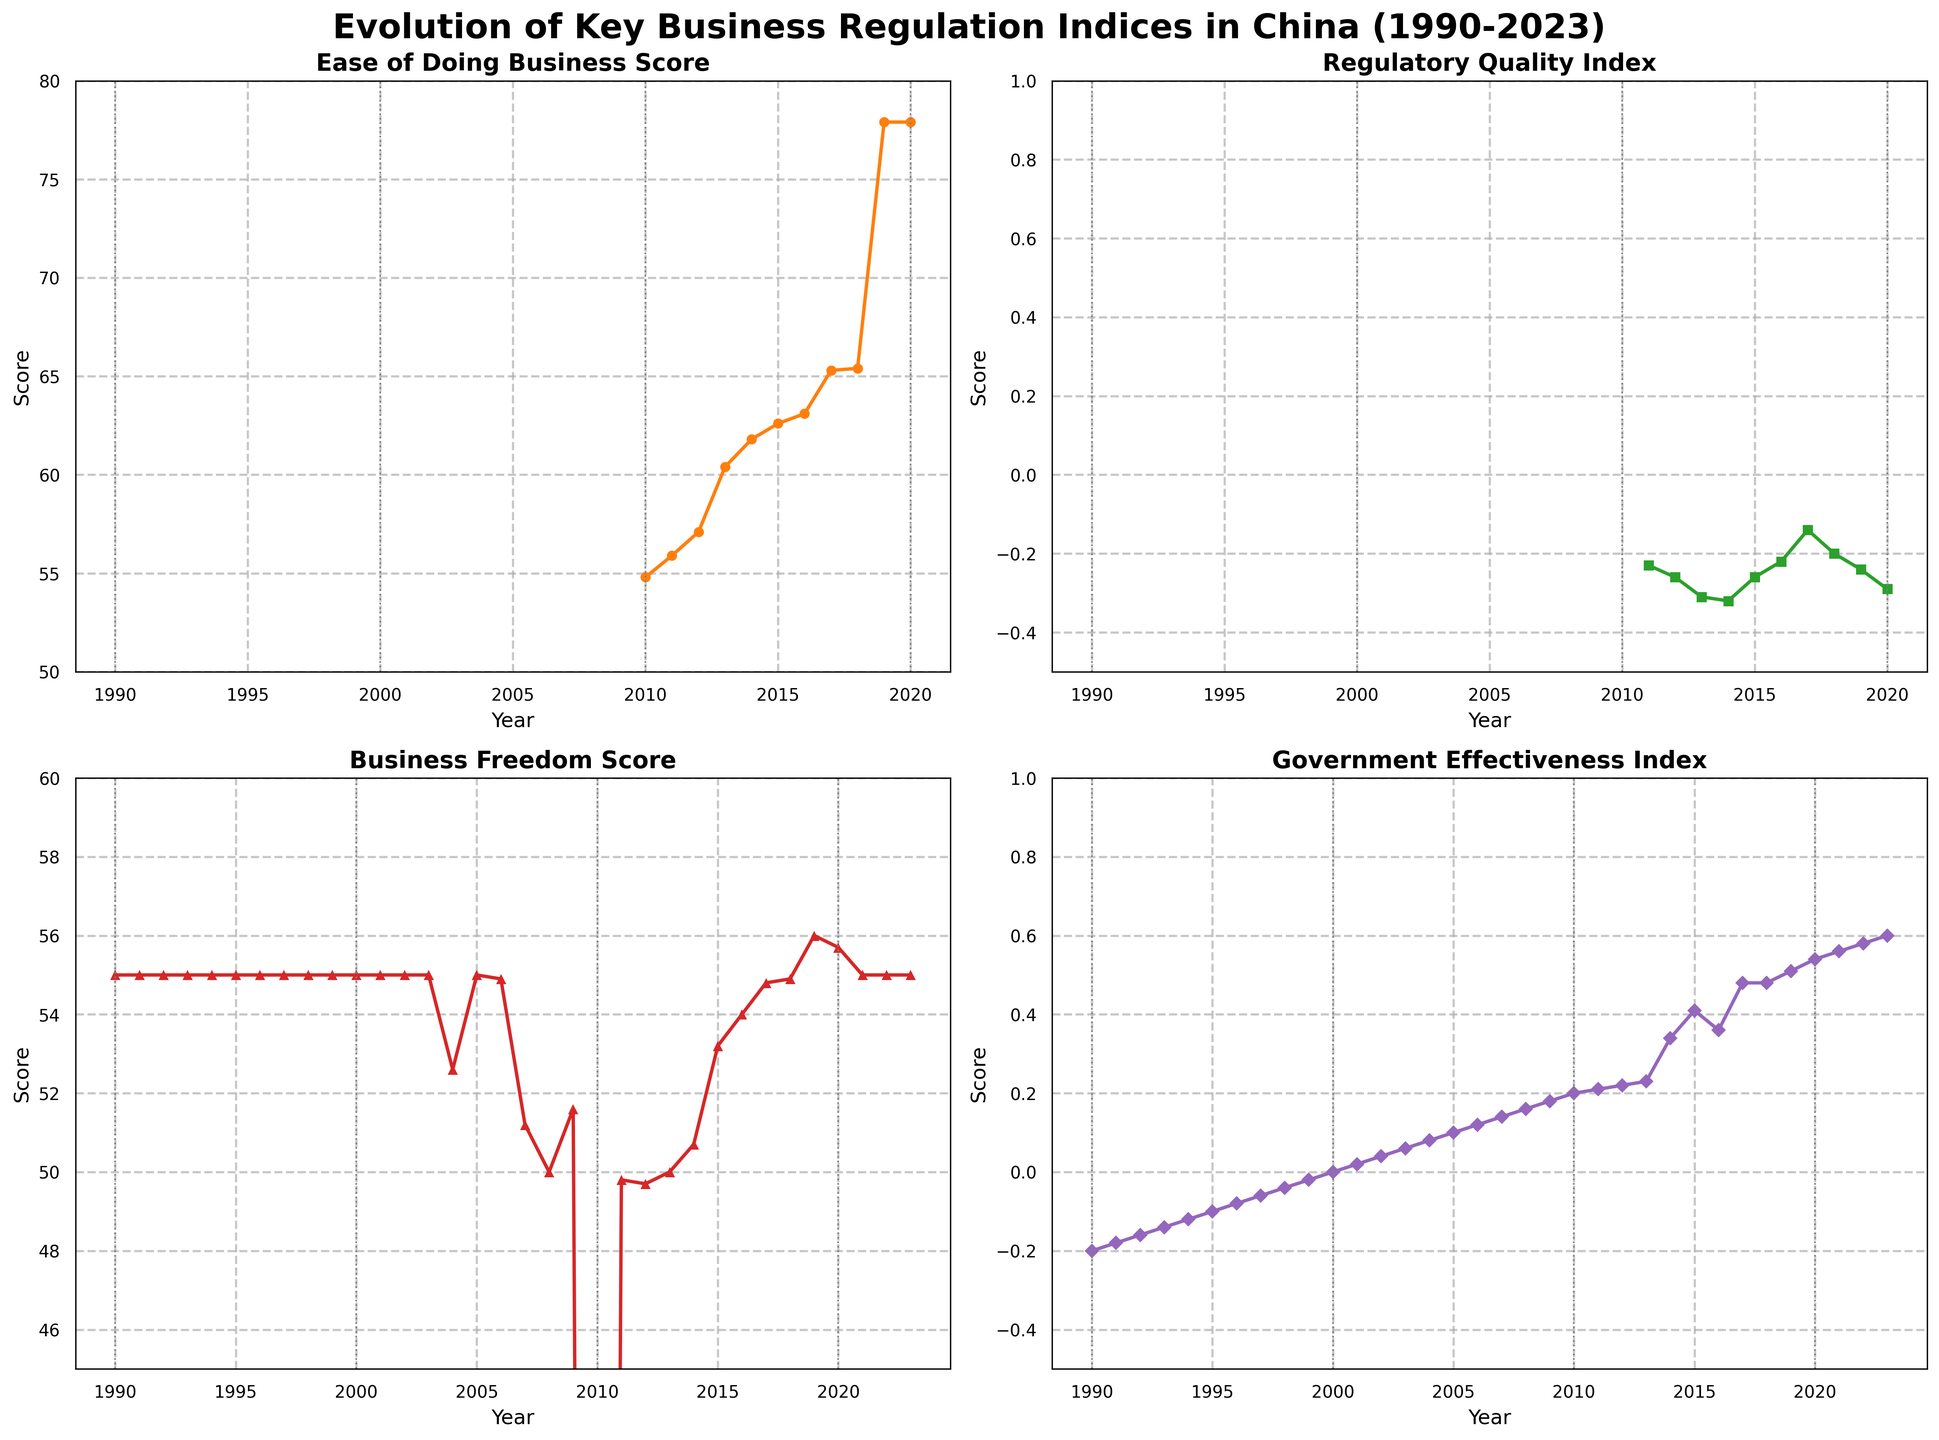What trend is observed in the 'Ease of Doing Business Score' between 2010 and 2020? The 'Ease of Doing Business Score' shows an upward trend between 2010 and 2020. In 2010, the score is 54.8, and it increases steadily until it reaches 77.9 in 2019 and remains constant in 2020.
Answer: Upward trend What is the approximate difference between the highest and lowest values of the 'Government Effectiveness Index'? The highest value of the 'Government Effectiveness Index' is approximately 0.60 observed in 2023, and the lowest value is approximately -0.20 observed in 1990. The difference can be calculated as 0.60 - (-0.20) = 0.80.
Answer: 0.80 Compare the 'Business Freedom Score' between 2008 and 2018. Which year has the higher score? The 'Business Freedom Score' in 2008 is 50.0, while in 2018 it is 54.9. By comparing these values, it is evident that the score is higher in 2018.
Answer: 2018 How would you describe the variation in the 'Regulatory Quality Index' from 2010 to 2020? The 'Regulatory Quality Index' declines slightly overall from 2010 (-0.23) to 2020 (-0.29). Despite minor fluctuations, the index maintains a generally stable and downward trend throughout this period.
Answer: Slight decline Considering the 'Government Effectiveness Index', identify the pattern observed around major years like 1990, 2000, 2010, and 2020. In 1990, the 'Government Effectiveness Index' begins at -0.20. It gradually improves to 0.00 by 2000, then further increases to 0.20 by 2010, and reaches its highest value at around 0.54 by 2020. This indicates a consistent improvement over these major years.
Answer: Consistent improvement Which index showed the most significant improvement between 1990 and 2020? The 'Government Effectiveness Index' demonstrated the most significant improvement, starting from -0.20 in 1990 and reaching 0.54 in 2020, reflecting a substantial positive change over the period.
Answer: Government Effectiveness Index What is the average 'Ease of Doing Business Score' from 2010 to 2020? The scores from 2010 to 2020 are: 54.8, 55.9, 57.1, 60.4, 61.8, 62.6, 63.1, 65.3, 65.4, 77.9, 77.9. Adding these values gives 697.2, and dividing by the number of years (11) yields an average of approximately 63.38.
Answer: 63.38 How does the variability in 'Business Freedom Score' from 2007 to 2020 compare to previous years? From 2007 to 2020, the 'Business Freedom Score' shows moderate variability, fluctuating between 51.2 and 56.0. In contrast, the score was fixed at 55.0 from 1990 to 2006, showing no variability in earlier years. Thus, post-2007, the variability increases.
Answer: Increase in variability 